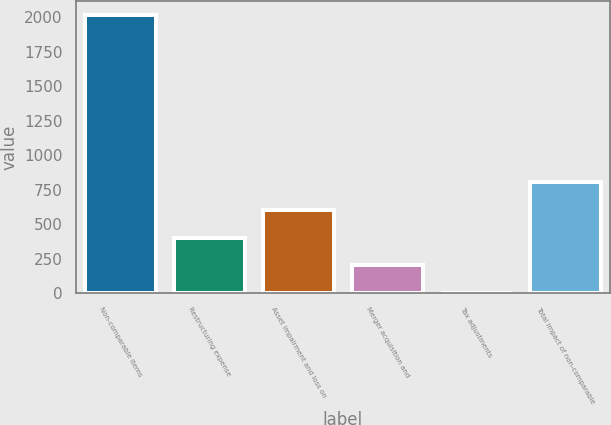<chart> <loc_0><loc_0><loc_500><loc_500><bar_chart><fcel>Non-comparable items<fcel>Restructuring expense<fcel>Asset impairment and loss on<fcel>Merger acquisition and<fcel>Tax adjustments<fcel>Total impact of non-comparable<nl><fcel>2017<fcel>403.42<fcel>605.12<fcel>201.72<fcel>0.02<fcel>806.82<nl></chart> 